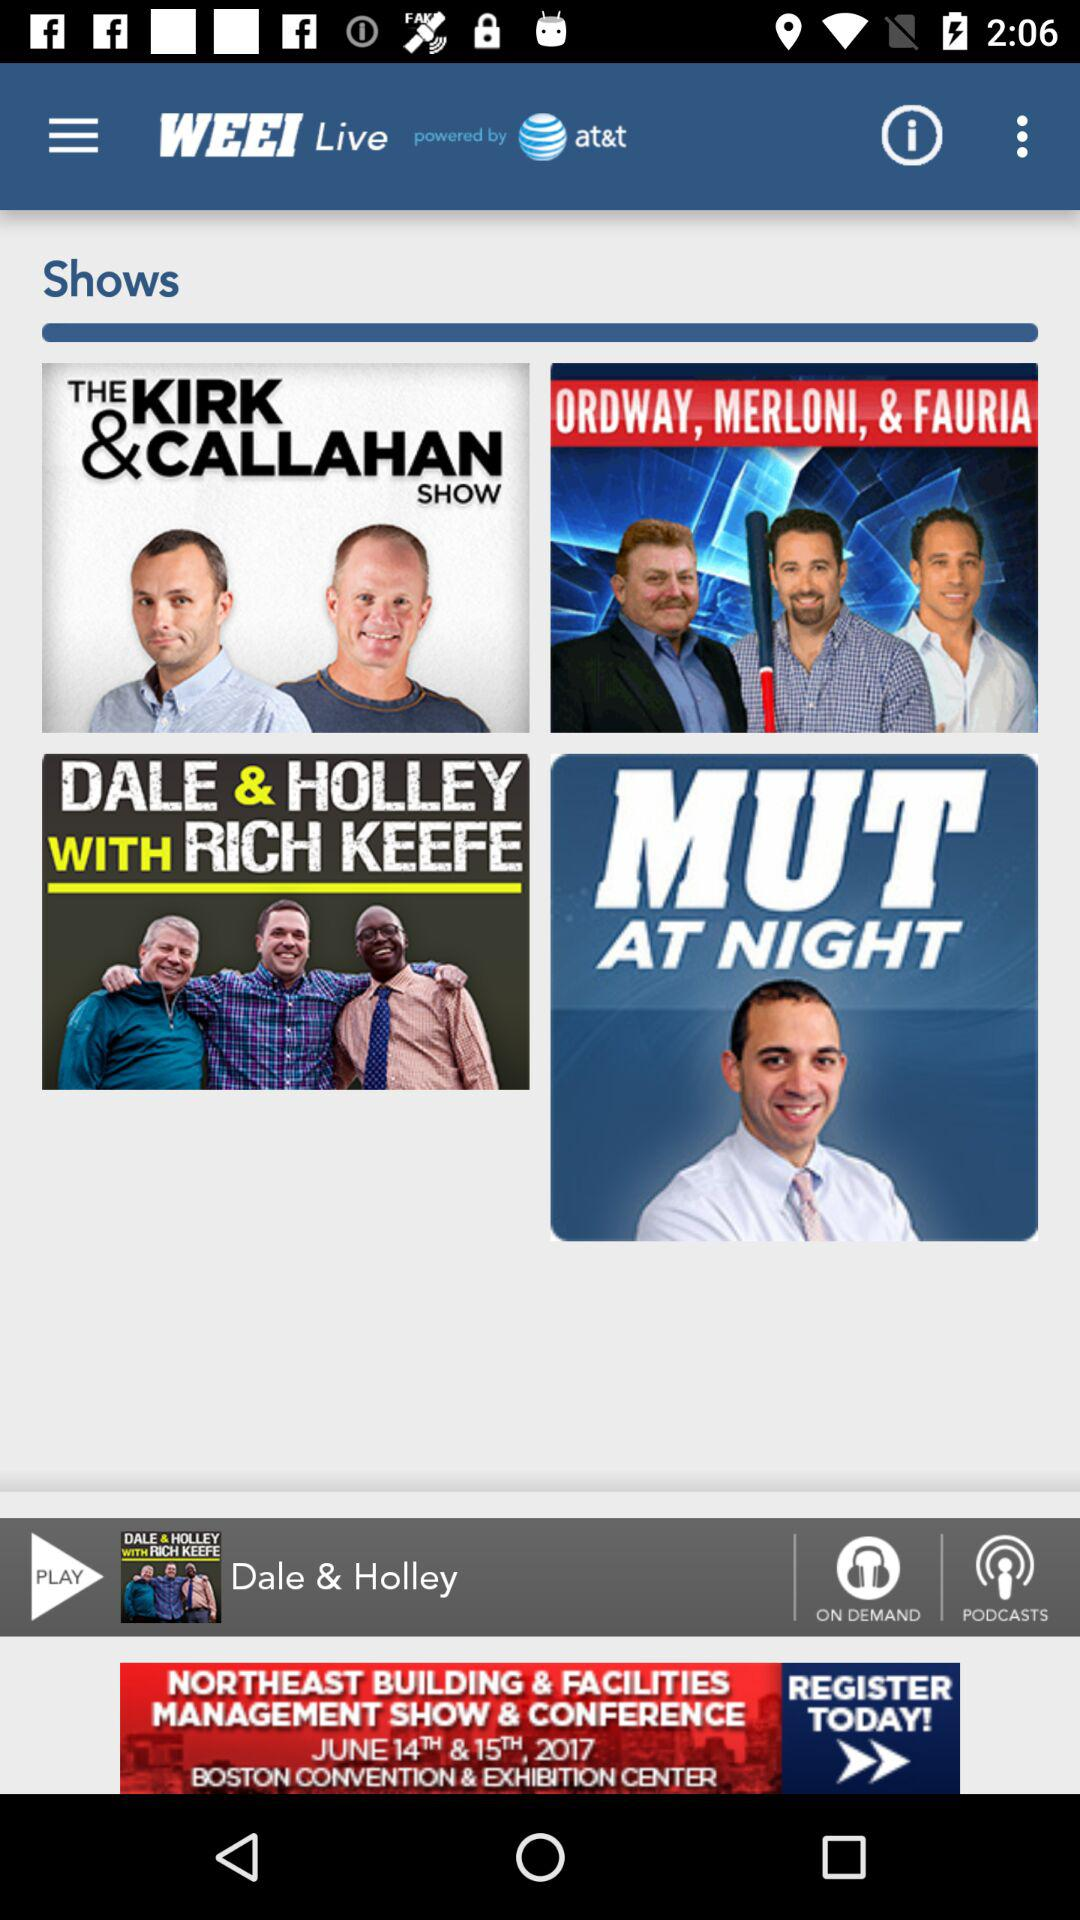What is the name of the channel? The name of the channel is "WEEI". 